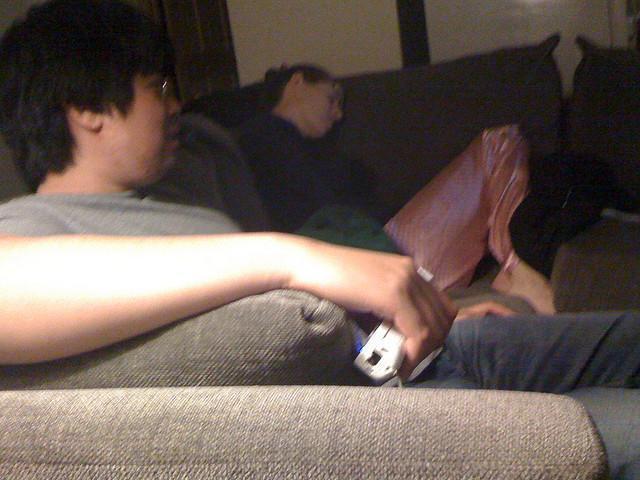How many couches can be seen?
Give a very brief answer. 2. How many people are there?
Give a very brief answer. 2. How many of the train cars are yellow and red?
Give a very brief answer. 0. 